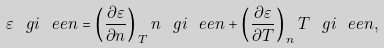<formula> <loc_0><loc_0><loc_500><loc_500>\varepsilon ^ { \ } g i _ { \ } e e n = \left ( \frac { \partial \varepsilon } { \partial n } \right ) _ { \, T } n ^ { \ } g i _ { \ } e e n + \left ( \frac { \partial \varepsilon } { \partial T } \right ) _ { \, n } T ^ { \ } g i _ { \ } e e n ,</formula> 